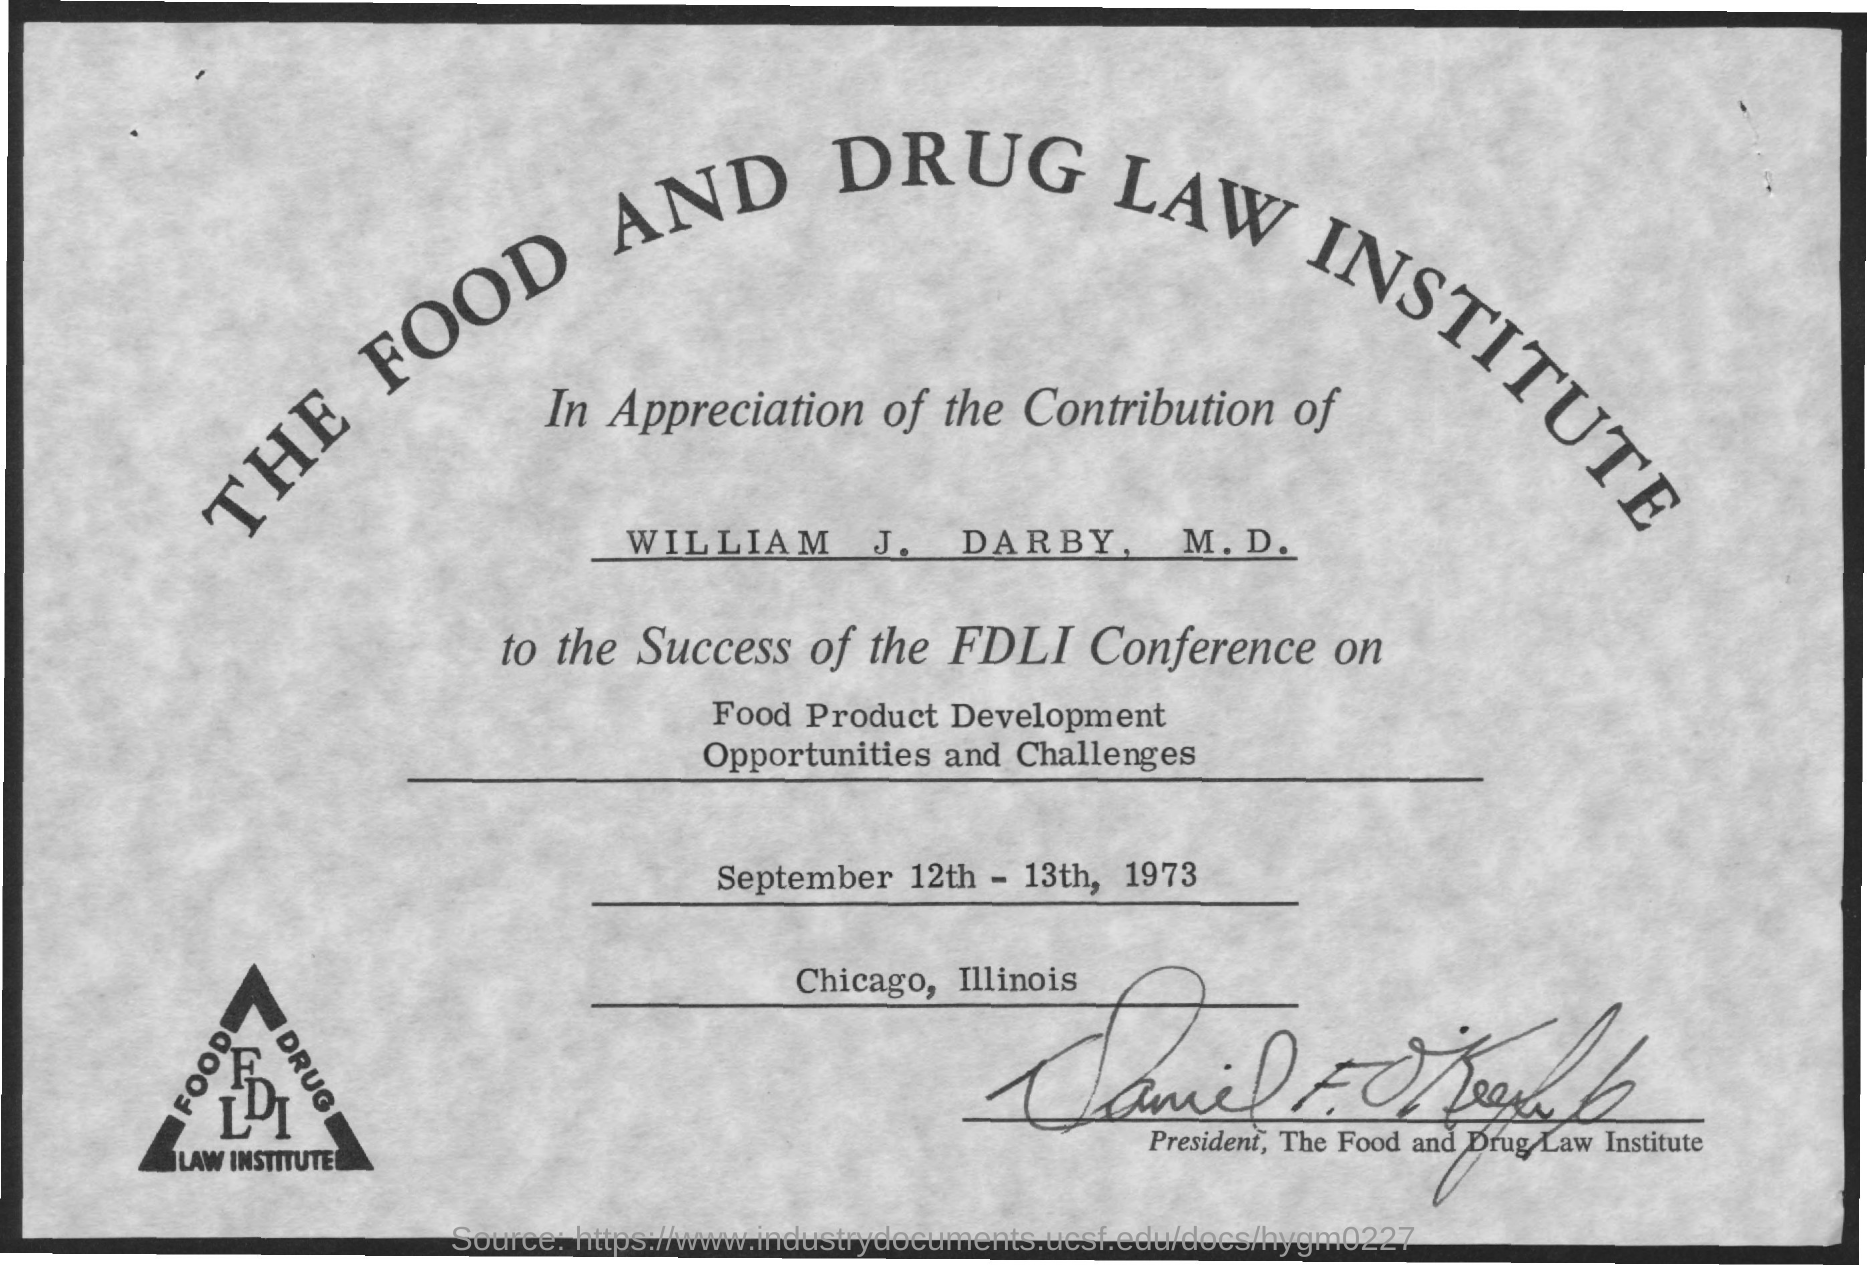The certificate is from which institute?
Your answer should be compact. The food and drug law institute. Whose contribution is appreciated?
Your response must be concise. William J. Darby, m.d. What is the conference name?
Your answer should be compact. FDLI. What is the conference on?
Provide a short and direct response. Food product development opportunities and challenges. When was the conference held?
Offer a very short reply. September 12th - 13th, 1973. In which city was the conference held?
Give a very brief answer. Chicago, illinois. 